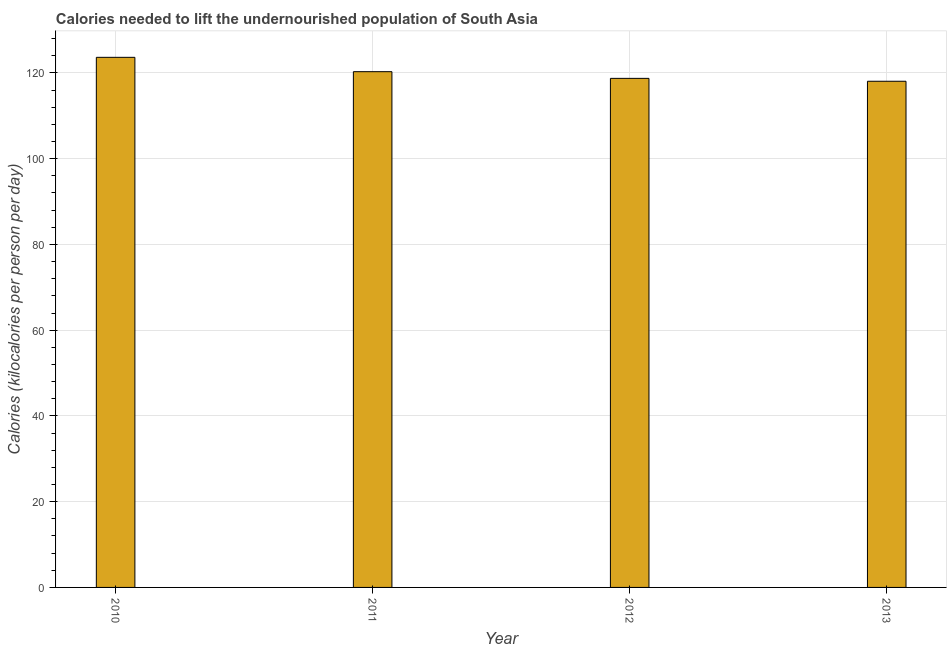Does the graph contain grids?
Give a very brief answer. Yes. What is the title of the graph?
Your response must be concise. Calories needed to lift the undernourished population of South Asia. What is the label or title of the X-axis?
Ensure brevity in your answer.  Year. What is the label or title of the Y-axis?
Make the answer very short. Calories (kilocalories per person per day). What is the depth of food deficit in 2012?
Offer a terse response. 118.72. Across all years, what is the maximum depth of food deficit?
Ensure brevity in your answer.  123.63. Across all years, what is the minimum depth of food deficit?
Your response must be concise. 118.05. In which year was the depth of food deficit maximum?
Provide a short and direct response. 2010. What is the sum of the depth of food deficit?
Your answer should be compact. 480.68. What is the difference between the depth of food deficit in 2012 and 2013?
Give a very brief answer. 0.67. What is the average depth of food deficit per year?
Offer a terse response. 120.17. What is the median depth of food deficit?
Give a very brief answer. 119.5. Do a majority of the years between 2011 and 2010 (inclusive) have depth of food deficit greater than 92 kilocalories?
Your response must be concise. No. What is the ratio of the depth of food deficit in 2010 to that in 2012?
Make the answer very short. 1.04. Is the depth of food deficit in 2011 less than that in 2013?
Your response must be concise. No. Is the difference between the depth of food deficit in 2010 and 2012 greater than the difference between any two years?
Provide a succinct answer. No. What is the difference between the highest and the second highest depth of food deficit?
Your response must be concise. 3.35. What is the difference between the highest and the lowest depth of food deficit?
Your response must be concise. 5.58. In how many years, is the depth of food deficit greater than the average depth of food deficit taken over all years?
Your answer should be compact. 2. How many years are there in the graph?
Provide a short and direct response. 4. What is the Calories (kilocalories per person per day) of 2010?
Ensure brevity in your answer.  123.63. What is the Calories (kilocalories per person per day) in 2011?
Provide a succinct answer. 120.28. What is the Calories (kilocalories per person per day) in 2012?
Provide a short and direct response. 118.72. What is the Calories (kilocalories per person per day) of 2013?
Your answer should be very brief. 118.05. What is the difference between the Calories (kilocalories per person per day) in 2010 and 2011?
Give a very brief answer. 3.35. What is the difference between the Calories (kilocalories per person per day) in 2010 and 2012?
Ensure brevity in your answer.  4.91. What is the difference between the Calories (kilocalories per person per day) in 2010 and 2013?
Offer a terse response. 5.58. What is the difference between the Calories (kilocalories per person per day) in 2011 and 2012?
Offer a terse response. 1.56. What is the difference between the Calories (kilocalories per person per day) in 2011 and 2013?
Keep it short and to the point. 2.23. What is the difference between the Calories (kilocalories per person per day) in 2012 and 2013?
Offer a terse response. 0.67. What is the ratio of the Calories (kilocalories per person per day) in 2010 to that in 2011?
Give a very brief answer. 1.03. What is the ratio of the Calories (kilocalories per person per day) in 2010 to that in 2012?
Your answer should be very brief. 1.04. What is the ratio of the Calories (kilocalories per person per day) in 2010 to that in 2013?
Provide a succinct answer. 1.05. What is the ratio of the Calories (kilocalories per person per day) in 2011 to that in 2012?
Provide a succinct answer. 1.01. What is the ratio of the Calories (kilocalories per person per day) in 2011 to that in 2013?
Your response must be concise. 1.02. What is the ratio of the Calories (kilocalories per person per day) in 2012 to that in 2013?
Ensure brevity in your answer.  1.01. 